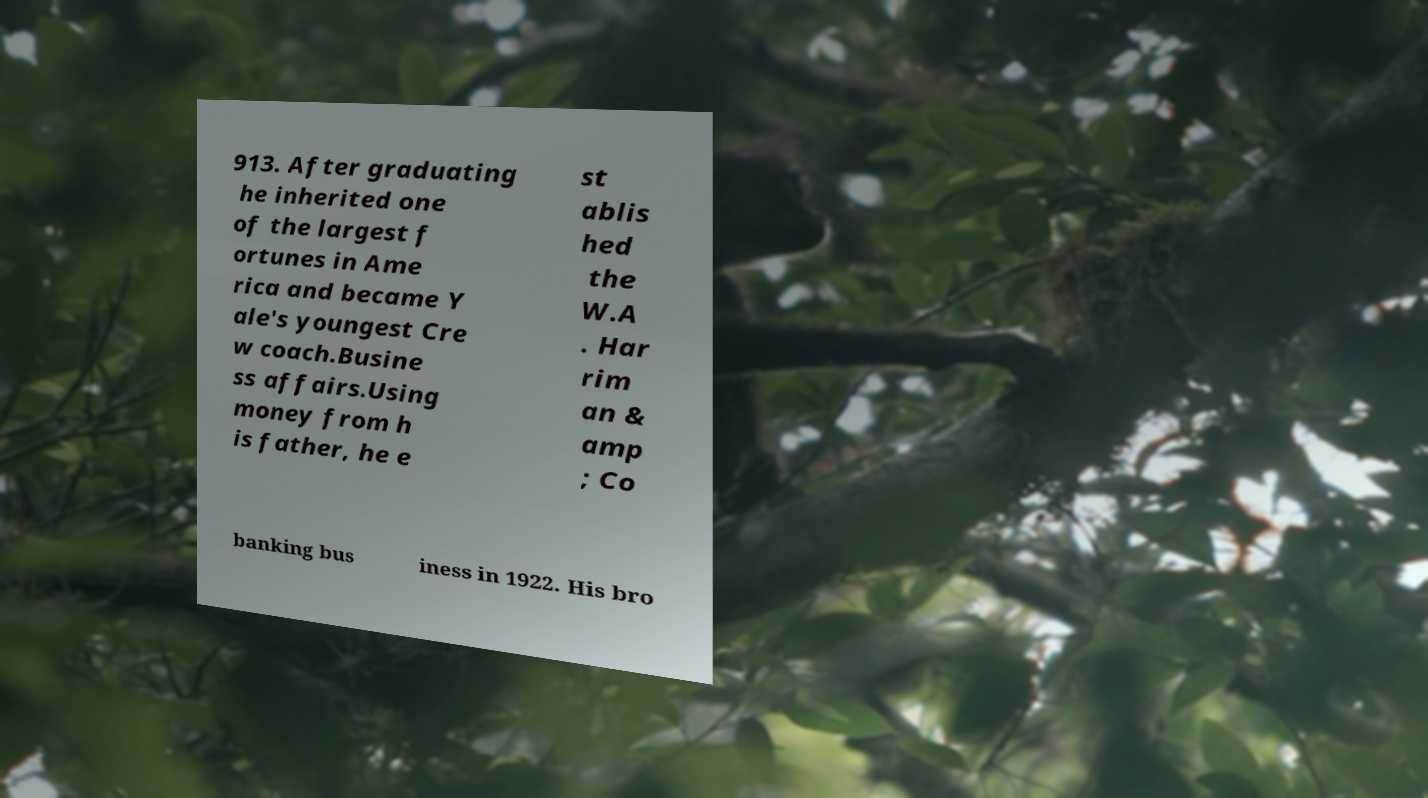For documentation purposes, I need the text within this image transcribed. Could you provide that? 913. After graduating he inherited one of the largest f ortunes in Ame rica and became Y ale's youngest Cre w coach.Busine ss affairs.Using money from h is father, he e st ablis hed the W.A . Har rim an & amp ; Co banking bus iness in 1922. His bro 